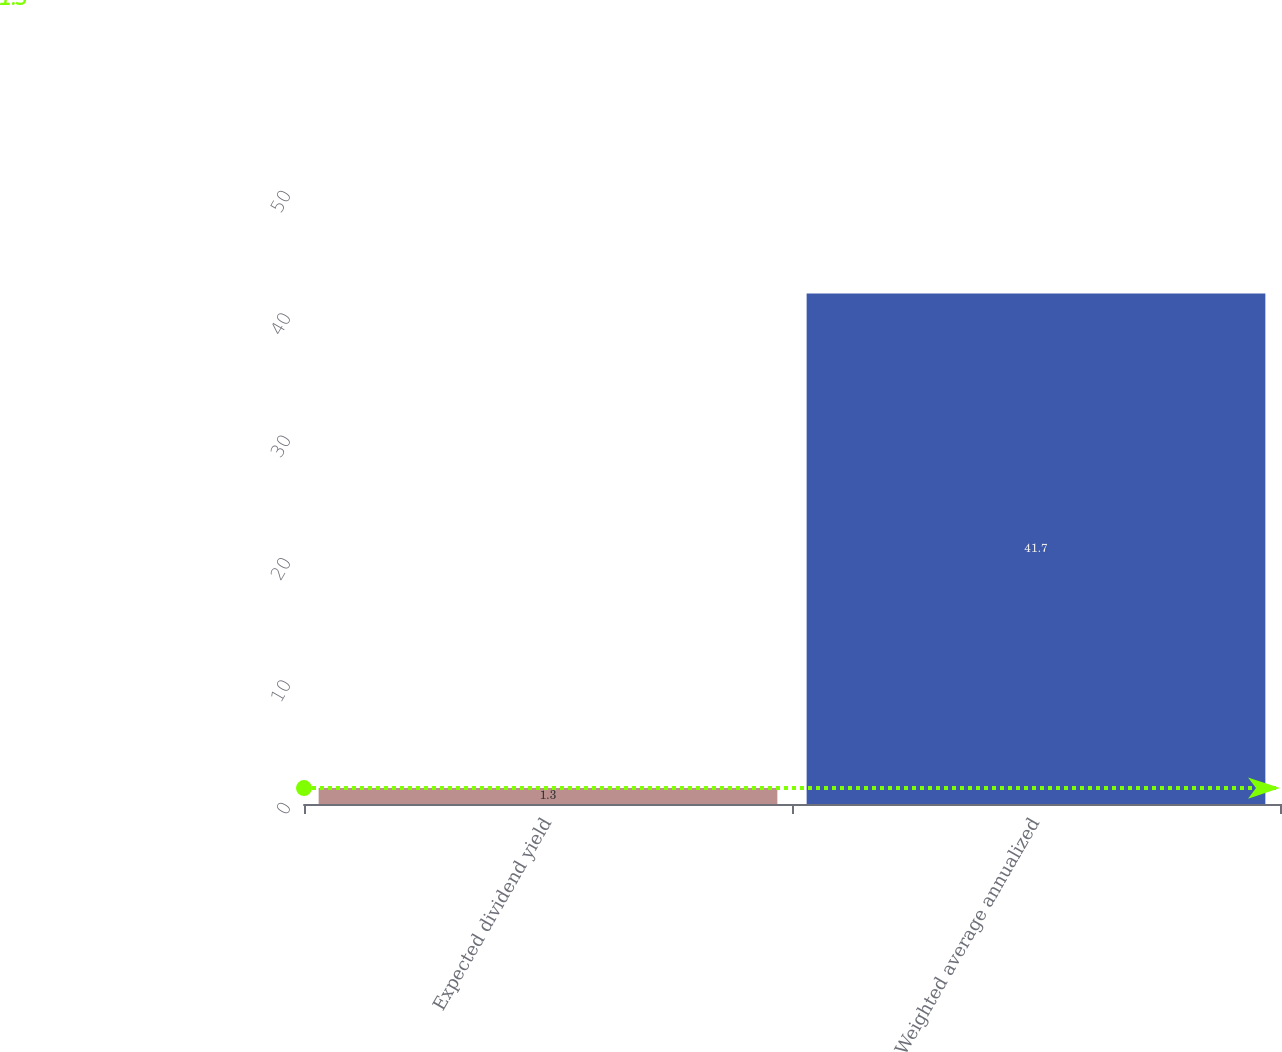Convert chart to OTSL. <chart><loc_0><loc_0><loc_500><loc_500><bar_chart><fcel>Expected dividend yield<fcel>Weighted average annualized<nl><fcel>1.3<fcel>41.7<nl></chart> 